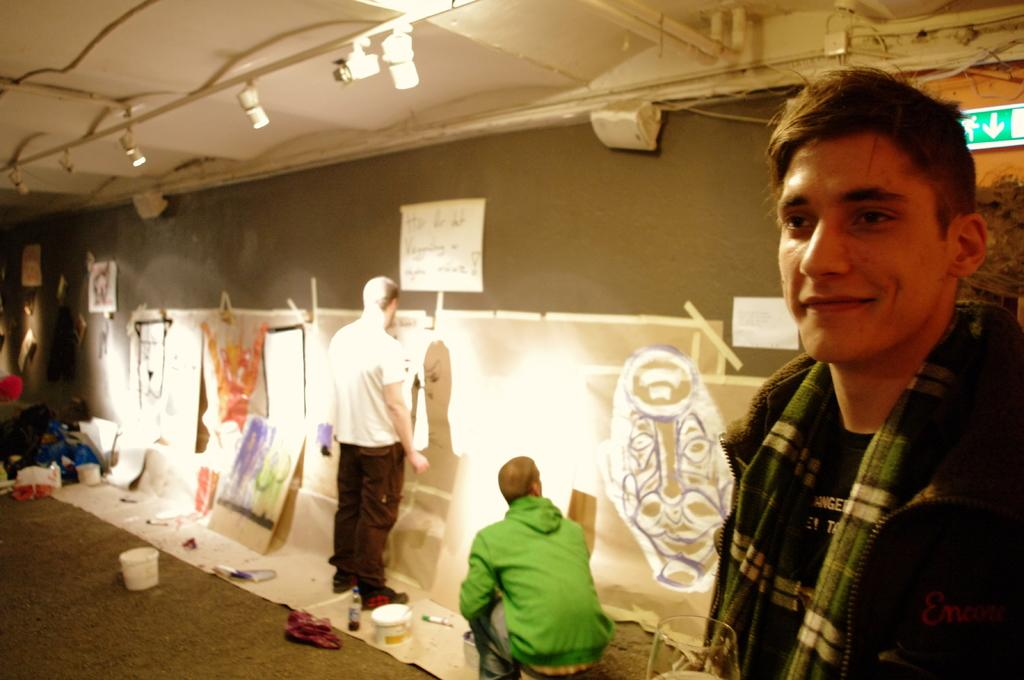What is the man in the image doing? The man in the image is standing and smiling. What is located behind the man in the image? There is a sign board behind the man. What is the board in the image used for? The board in the image is used for displaying information or advertisements. What type of containers can be seen in the image? There are buckets in the image. What is on the surface in the image? There are objects on the surface in the image. How many people are present in the image? There are two people in the image. What is visible at the top of the image? There are lights visible at the top of the image. What type of stew is being prepared in the image? There is no stew being prepared in the image; it does not contain any cooking or food preparation activities. 